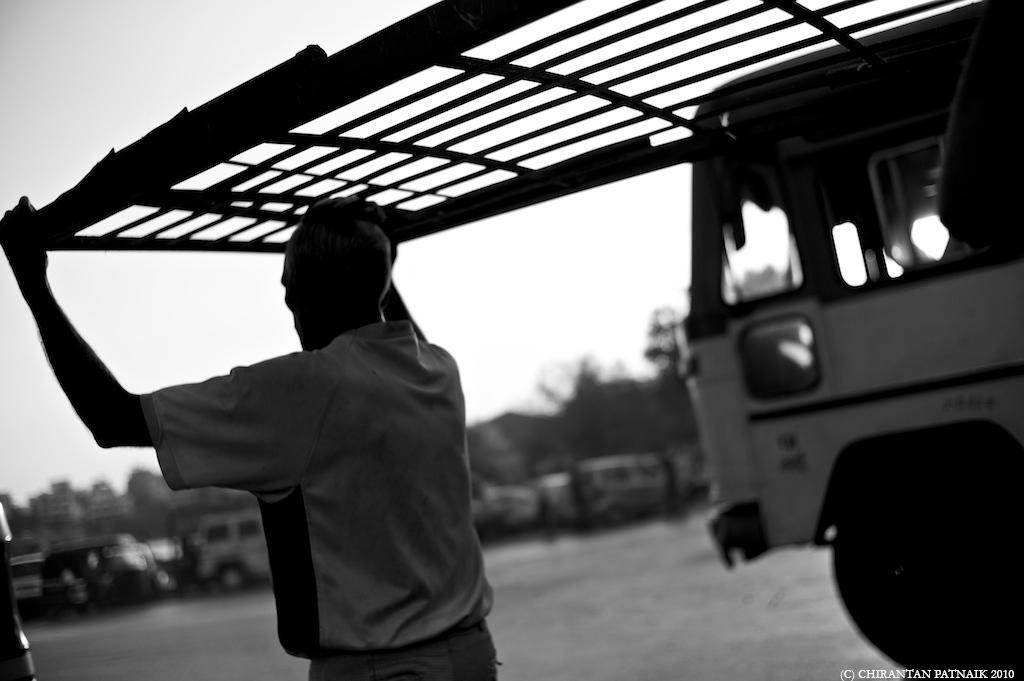How would you summarize this image in a sentence or two? In this image we can see few people. There are two persons carrying an object in the image. There is a sky in the image. There are many trees in the image. There are many vehicles in the image. 